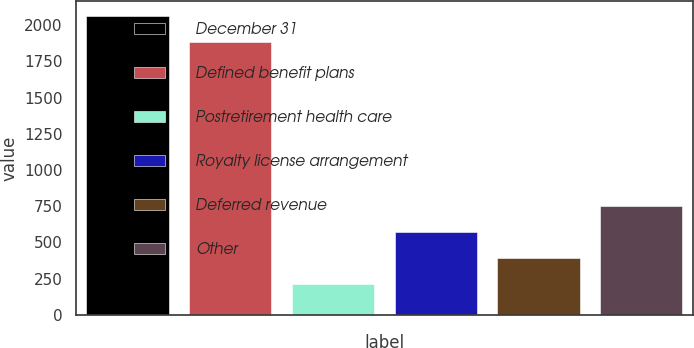Convert chart to OTSL. <chart><loc_0><loc_0><loc_500><loc_500><bar_chart><fcel>December 31<fcel>Defined benefit plans<fcel>Postretirement health care<fcel>Royalty license arrangement<fcel>Deferred revenue<fcel>Other<nl><fcel>2061.2<fcel>1882<fcel>214<fcel>572.4<fcel>393.2<fcel>751.6<nl></chart> 